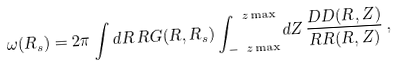Convert formula to latex. <formula><loc_0><loc_0><loc_500><loc_500>\omega ( R _ { s } ) = 2 \pi \int d R \, R G ( R , R _ { s } ) \int _ { - \ z \max } ^ { \ z \max } d Z \, \frac { D D ( R , Z ) } { R R ( R , Z ) } \, ,</formula> 